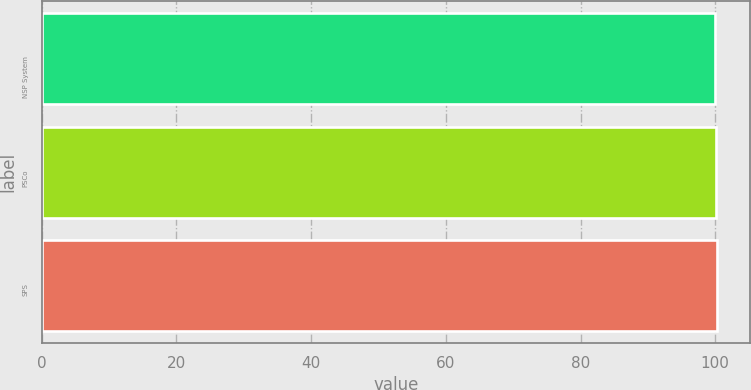Convert chart. <chart><loc_0><loc_0><loc_500><loc_500><bar_chart><fcel>NSP System<fcel>PSCo<fcel>SPS<nl><fcel>100<fcel>100.1<fcel>100.2<nl></chart> 